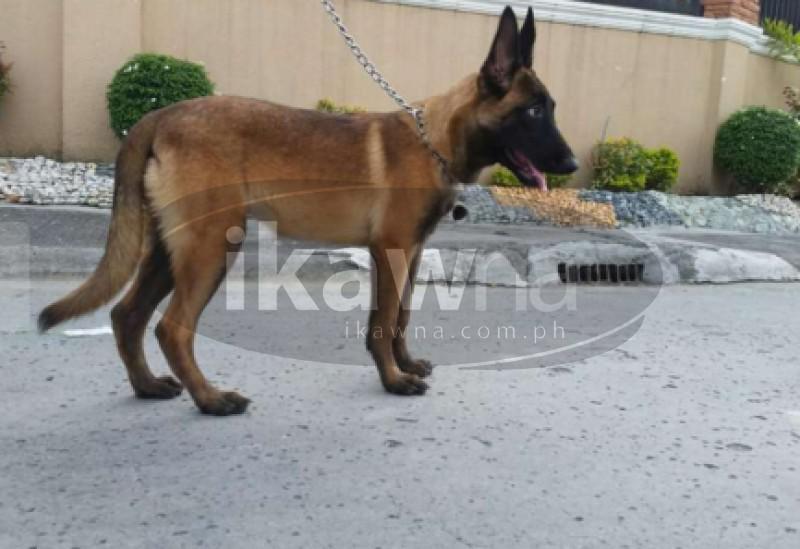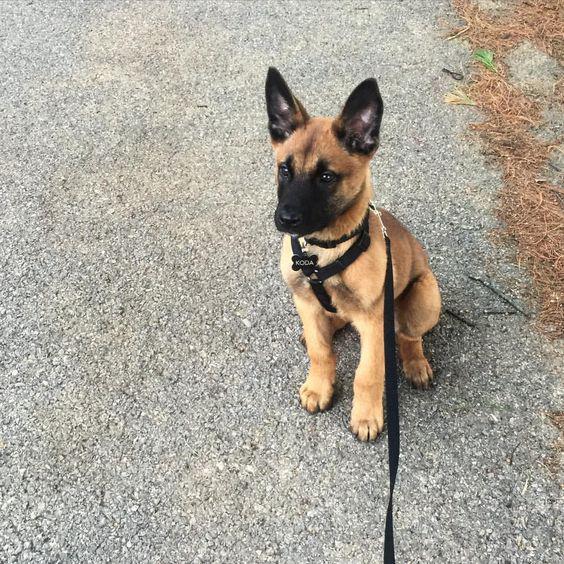The first image is the image on the left, the second image is the image on the right. Considering the images on both sides, is "A german shepherd wearing a collar without a leash stands on the grass on all fours, with its tail nearly parallel to the ground." valid? Answer yes or no. No. The first image is the image on the left, the second image is the image on the right. Considering the images on both sides, is "One dog is on a leash, while a second dog is not, but is wearing a collar and is standing on grass with its tongue out and tail outstretched." valid? Answer yes or no. No. 